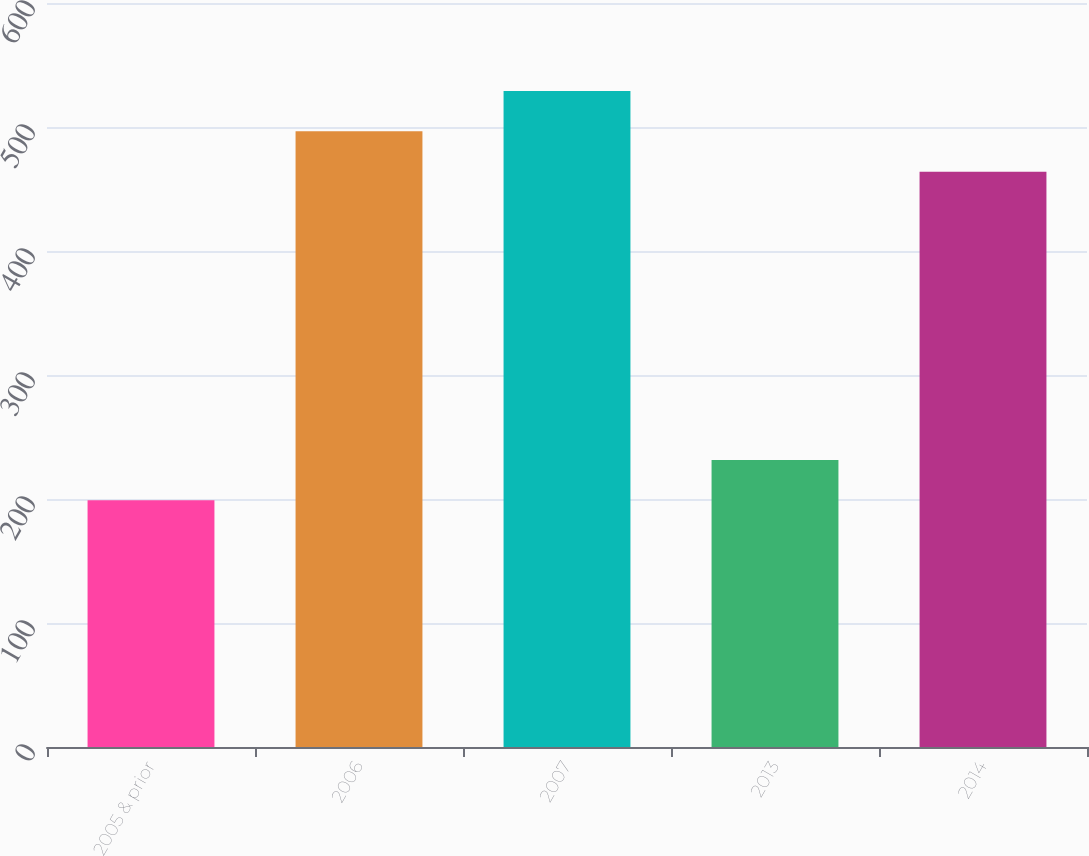Convert chart. <chart><loc_0><loc_0><loc_500><loc_500><bar_chart><fcel>2005 & prior<fcel>2006<fcel>2007<fcel>2013<fcel>2014<nl><fcel>199<fcel>496.5<fcel>529<fcel>231.5<fcel>464<nl></chart> 